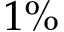<formula> <loc_0><loc_0><loc_500><loc_500>1 \%</formula> 